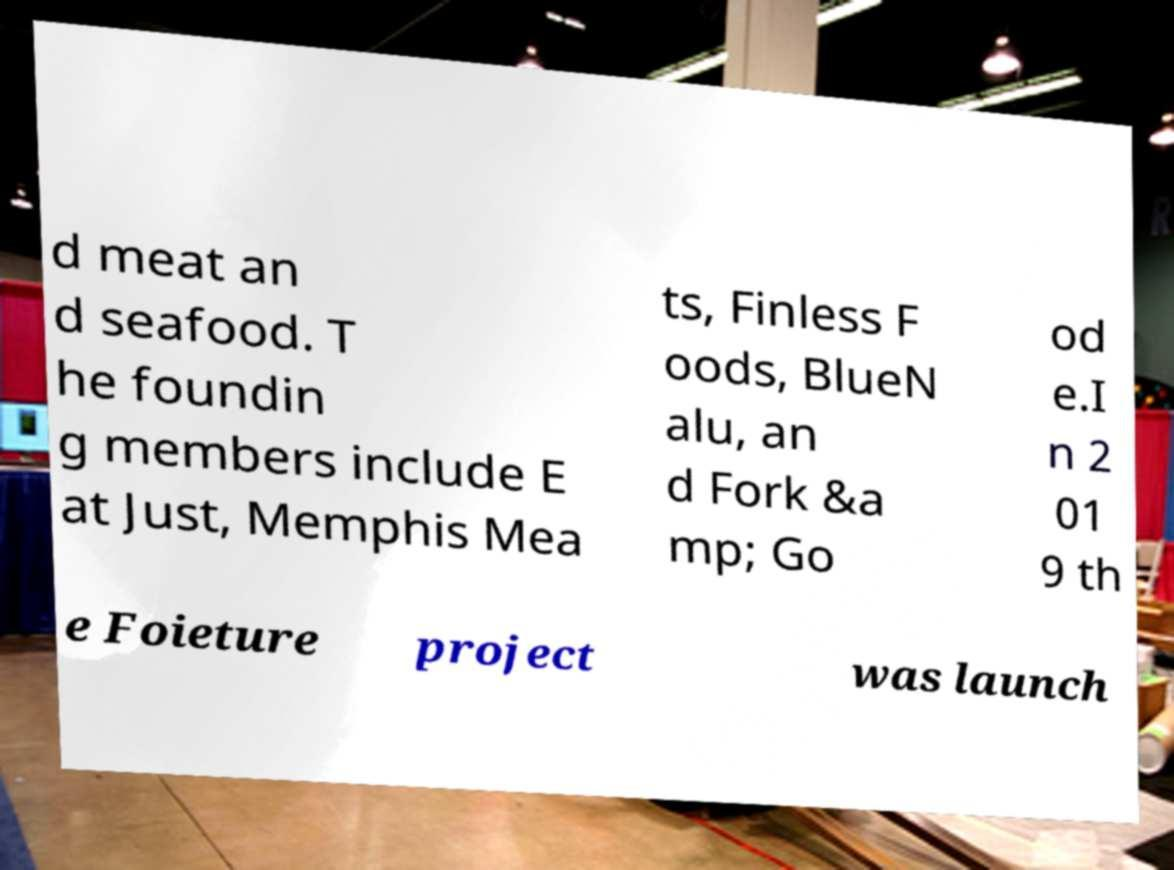What messages or text are displayed in this image? I need them in a readable, typed format. d meat an d seafood. T he foundin g members include E at Just, Memphis Mea ts, Finless F oods, BlueN alu, an d Fork &a mp; Go od e.I n 2 01 9 th e Foieture project was launch 